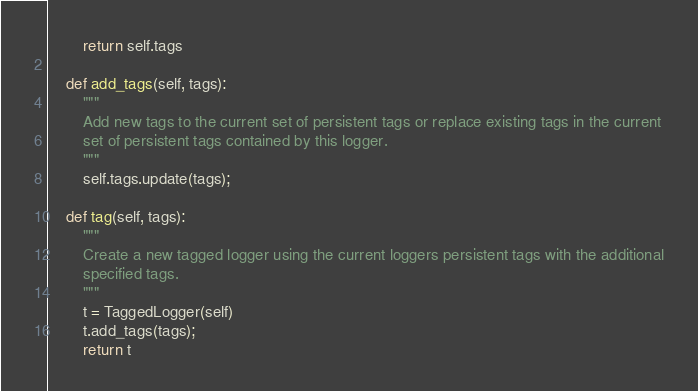<code> <loc_0><loc_0><loc_500><loc_500><_Python_>        return self.tags

    def add_tags(self, tags):
        """
        Add new tags to the current set of persistent tags or replace existing tags in the current
        set of persistent tags contained by this logger.
        """
        self.tags.update(tags);

    def tag(self, tags):
        """
        Create a new tagged logger using the current loggers persistent tags with the additional
        specified tags.
        """
        t = TaggedLogger(self)
        t.add_tags(tags);
        return t
</code> 